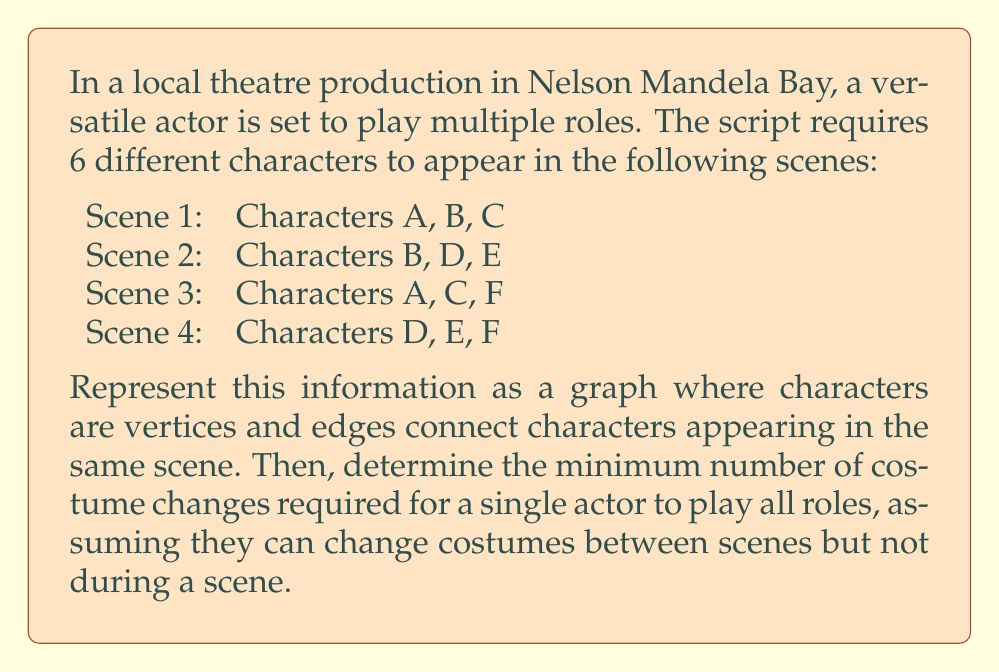Provide a solution to this math problem. To solve this problem, we'll use concepts from graph theory:

1) First, let's create the graph:
   - Vertices: A, B, C, D, E, F (representing the characters)
   - Edges: (A,B), (A,C), (B,C), (B,D), (B,E), (D,E), (A,C), (A,F), (C,F), (D,E), (D,F), (E,F)

[asy]
unitsize(1cm);
pair A=(0,2), B=(2,2), C=(1,0), D=(4,2), E=(5,0), F=(3,0);
draw(A--B--C--A, black);
draw(B--D--E, black);
draw(A--F--C, black);
draw(D--F--E, black);
dot(A); dot(B); dot(C); dot(D); dot(E); dot(F);
label("A", A, NW);
label("B", B, N);
label("C", C, SW);
label("D", D, N);
label("E", E, SE);
label("F", F, S);
[/asy]

2) This problem is equivalent to finding the chromatic number of the graph. The chromatic number is the minimum number of colors needed to color the vertices so that no adjacent vertices have the same color.

3) We can use a greedy coloring algorithm:
   - Start with character A, assign it color 1.
   - For B, it's connected to A, so assign color 2.
   - For C, it's connected to A and B, so assign color 3.
   - For D, it's connected to B, so we can use color 1.
   - For E, it's connected to B and D, so we need color 3.
   - For F, it's connected to A, C, D, and E, so we need a new color, 4.

4) The chromatic number of this graph is 4, which means we need at least 4 different costumes.

5) This coloring ensures that characters in the same scene always have different colors (costumes), allowing a single actor to play all roles with costume changes only between scenes.
Answer: The minimum number of costume changes required is 3, as the actor needs 4 different costumes in total. 